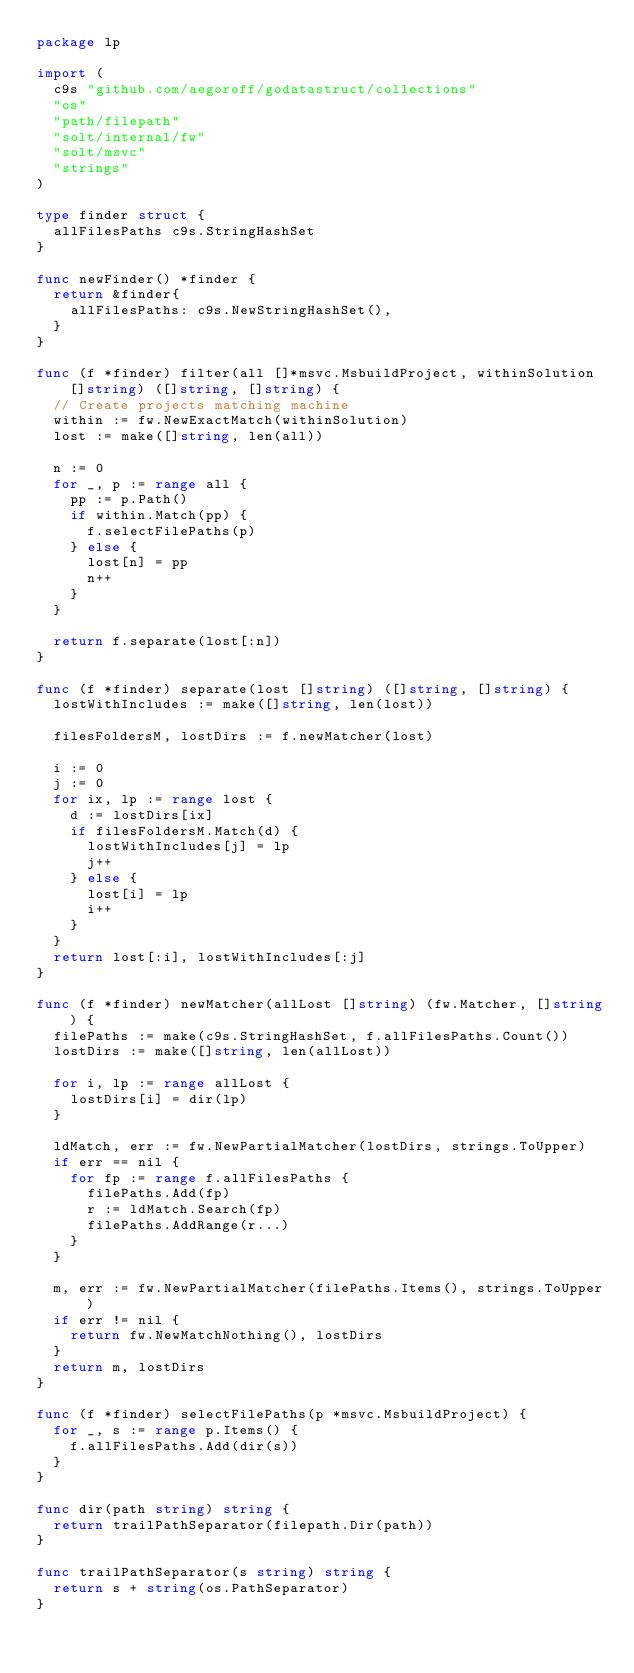Convert code to text. <code><loc_0><loc_0><loc_500><loc_500><_Go_>package lp

import (
	c9s "github.com/aegoroff/godatastruct/collections"
	"os"
	"path/filepath"
	"solt/internal/fw"
	"solt/msvc"
	"strings"
)

type finder struct {
	allFilesPaths c9s.StringHashSet
}

func newFinder() *finder {
	return &finder{
		allFilesPaths: c9s.NewStringHashSet(),
	}
}

func (f *finder) filter(all []*msvc.MsbuildProject, withinSolution []string) ([]string, []string) {
	// Create projects matching machine
	within := fw.NewExactMatch(withinSolution)
	lost := make([]string, len(all))

	n := 0
	for _, p := range all {
		pp := p.Path()
		if within.Match(pp) {
			f.selectFilePaths(p)
		} else {
			lost[n] = pp
			n++
		}
	}

	return f.separate(lost[:n])
}

func (f *finder) separate(lost []string) ([]string, []string) {
	lostWithIncludes := make([]string, len(lost))

	filesFoldersM, lostDirs := f.newMatcher(lost)

	i := 0
	j := 0
	for ix, lp := range lost {
		d := lostDirs[ix]
		if filesFoldersM.Match(d) {
			lostWithIncludes[j] = lp
			j++
		} else {
			lost[i] = lp
			i++
		}
	}
	return lost[:i], lostWithIncludes[:j]
}

func (f *finder) newMatcher(allLost []string) (fw.Matcher, []string) {
	filePaths := make(c9s.StringHashSet, f.allFilesPaths.Count())
	lostDirs := make([]string, len(allLost))

	for i, lp := range allLost {
		lostDirs[i] = dir(lp)
	}

	ldMatch, err := fw.NewPartialMatcher(lostDirs, strings.ToUpper)
	if err == nil {
		for fp := range f.allFilesPaths {
			filePaths.Add(fp)
			r := ldMatch.Search(fp)
			filePaths.AddRange(r...)
		}
	}

	m, err := fw.NewPartialMatcher(filePaths.Items(), strings.ToUpper)
	if err != nil {
		return fw.NewMatchNothing(), lostDirs
	}
	return m, lostDirs
}

func (f *finder) selectFilePaths(p *msvc.MsbuildProject) {
	for _, s := range p.Items() {
		f.allFilesPaths.Add(dir(s))
	}
}

func dir(path string) string {
	return trailPathSeparator(filepath.Dir(path))
}

func trailPathSeparator(s string) string {
	return s + string(os.PathSeparator)
}
</code> 